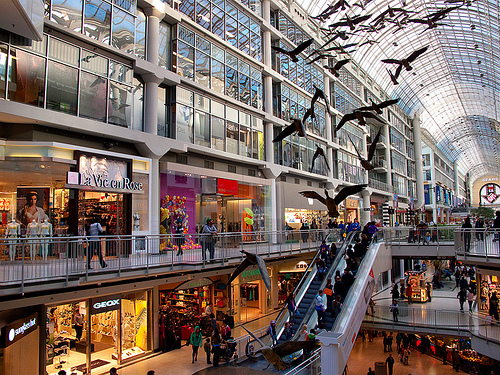<image>What famous song is also the name of a store pictured here? I don't know the famous song that is also the name of a store pictured here. It can be 'la vie en rose'. What fast food restaurant can be seen? I am not sure what fast food restaurant can be seen. It could be McDonald's or Starbucks. What fast food restaurant can be seen? I am not sure what fast food restaurant can be seen in the image. What famous song is also the name of a store pictured here? I don't know what famous song is also the name of a store pictured here. It could be "la vie en rose" or "rose". 